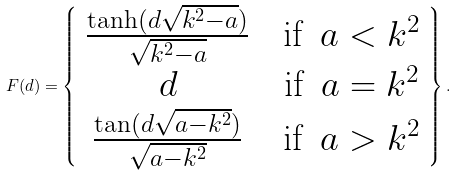<formula> <loc_0><loc_0><loc_500><loc_500>F ( d ) = \left \{ \begin{array} { c c c } \frac { \tanh ( d \sqrt { k ^ { 2 } - a } ) } { \sqrt { k ^ { 2 } - a } } & & \text {if\, $a<k^{2}$} \\ d & & \text {if\, $a=k^{2}$} \\ \frac { \tan ( d \sqrt { a - k ^ { 2 } } ) } { \sqrt { a - k ^ { 2 } } } & & \text {if\, $a>k^{2}$} \end{array} \right \} .</formula> 